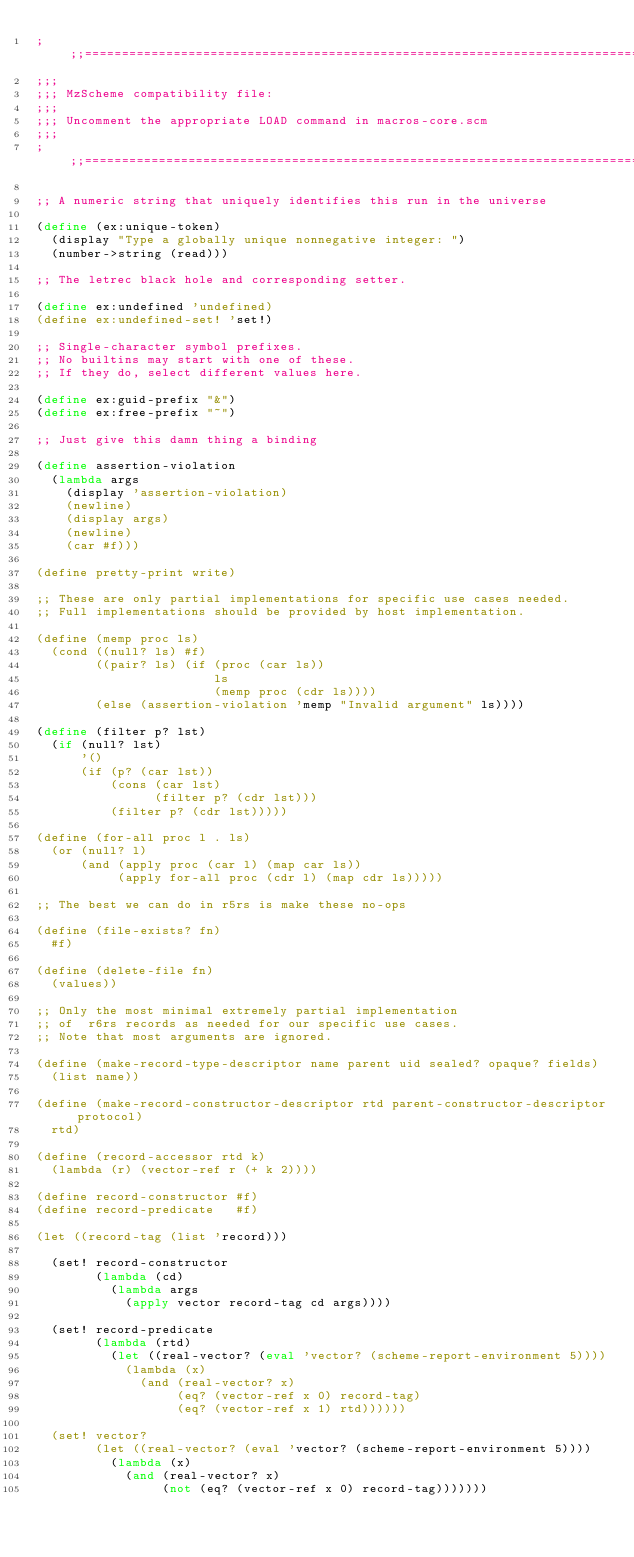<code> <loc_0><loc_0><loc_500><loc_500><_Scheme_>;;;===============================================================================
;;;
;;; MzScheme compatibility file:
;;;
;;; Uncomment the appropriate LOAD command in macros-core.scm
;;;
;;;===============================================================================

;; A numeric string that uniquely identifies this run in the universe

(define (ex:unique-token) 
  (display "Type a globally unique nonnegative integer: ")
  (number->string (read)))

;; The letrec black hole and corresponding setter.

(define ex:undefined 'undefined)
(define ex:undefined-set! 'set!)

;; Single-character symbol prefixes.
;; No builtins may start with one of these.
;; If they do, select different values here.

(define ex:guid-prefix "&")
(define ex:free-prefix "~")

;; Just give this damn thing a binding

(define assertion-violation 
  (lambda args 
    (display 'assertion-violation)
    (newline)
    (display args)
    (newline)
    (car #f)))

(define pretty-print write)

;; These are only partial implementations for specific use cases needed.
;; Full implementations should be provided by host implementation.

(define (memp proc ls)
  (cond ((null? ls) #f)
        ((pair? ls) (if (proc (car ls))
                        ls
                        (memp proc (cdr ls))))
        (else (assertion-violation 'memp "Invalid argument" ls))))

(define (filter p? lst)
  (if (null? lst)
      '()
      (if (p? (car lst))
          (cons (car lst)
                (filter p? (cdr lst)))
          (filter p? (cdr lst)))))

(define (for-all proc l . ls)
  (or (null? l)
      (and (apply proc (car l) (map car ls))
           (apply for-all proc (cdr l) (map cdr ls)))))

;; The best we can do in r5rs is make these no-ops

(define (file-exists? fn) 
  #f)

(define (delete-file fn)
  (values))

;; Only the most minimal extremely partial implementation
;; of  r6rs records as needed for our specific use cases.  
;; Note that most arguments are ignored.

(define (make-record-type-descriptor name parent uid sealed? opaque? fields)
  (list name))

(define (make-record-constructor-descriptor rtd parent-constructor-descriptor protocol)
  rtd)

(define (record-accessor rtd k)
  (lambda (r) (vector-ref r (+ k 2))))

(define record-constructor #f) 
(define record-predicate   #f) 

(let ((record-tag (list 'record)))

  (set! record-constructor 
        (lambda (cd) 
          (lambda args
            (apply vector record-tag cd args))))
        
  (set! record-predicate 
        (lambda (rtd) 
          (let ((real-vector? (eval 'vector? (scheme-report-environment 5))))
            (lambda (x)
              (and (real-vector? x)
                   (eq? (vector-ref x 0) record-tag)
                   (eq? (vector-ref x 1) rtd))))))
  
  (set! vector?
        (let ((real-vector? (eval 'vector? (scheme-report-environment 5))))
          (lambda (x)
            (and (real-vector? x)
                 (not (eq? (vector-ref x 0) record-tag)))))))


</code> 